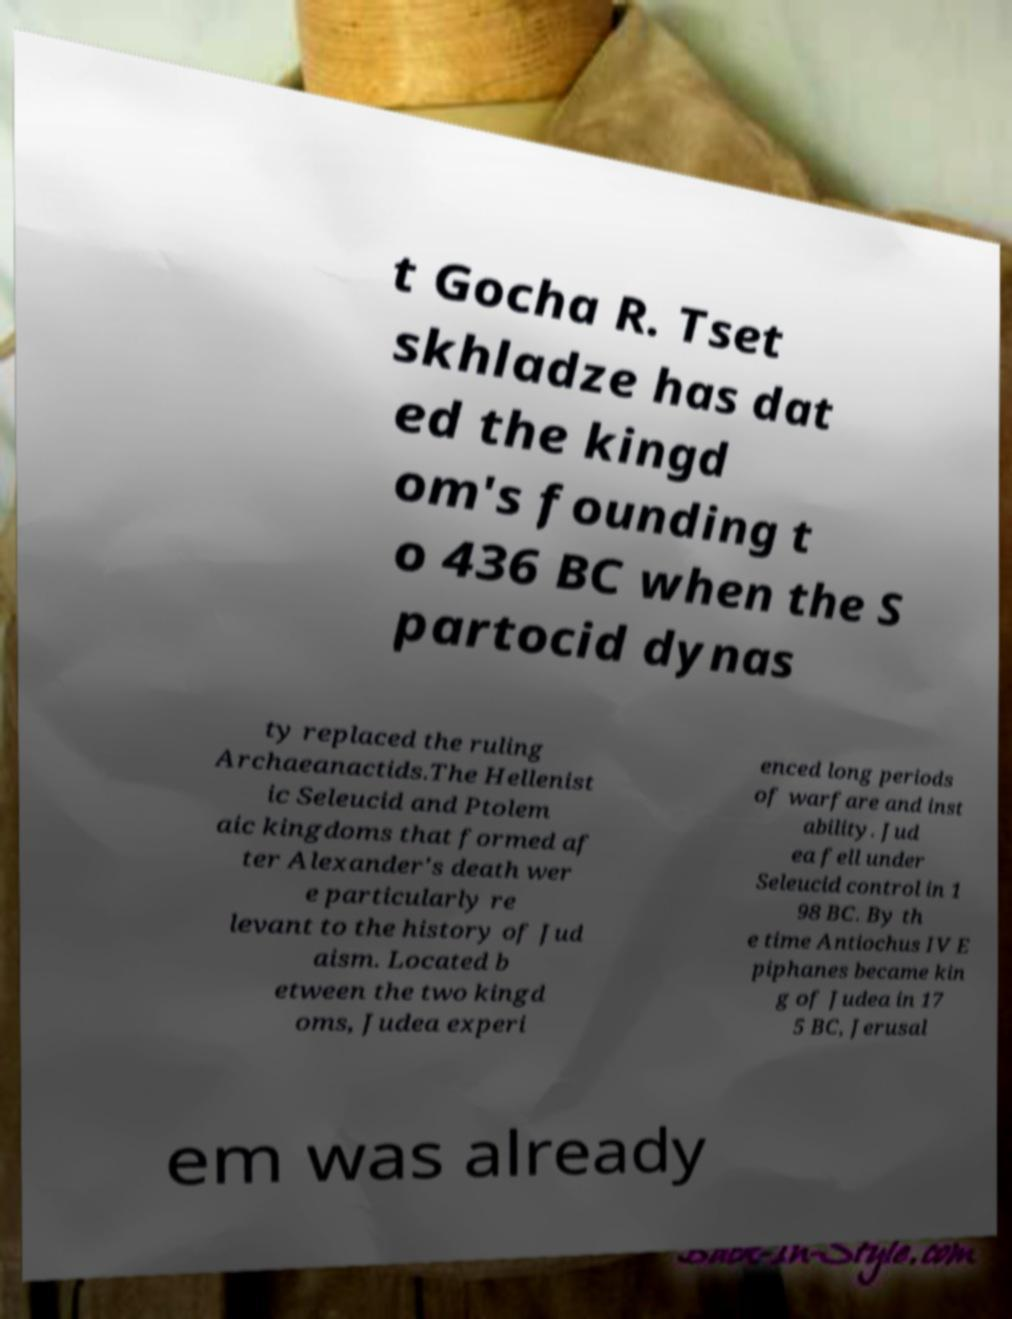Could you extract and type out the text from this image? t Gocha R. Tset skhladze has dat ed the kingd om's founding t o 436 BC when the S partocid dynas ty replaced the ruling Archaeanactids.The Hellenist ic Seleucid and Ptolem aic kingdoms that formed af ter Alexander's death wer e particularly re levant to the history of Jud aism. Located b etween the two kingd oms, Judea experi enced long periods of warfare and inst ability. Jud ea fell under Seleucid control in 1 98 BC. By th e time Antiochus IV E piphanes became kin g of Judea in 17 5 BC, Jerusal em was already 